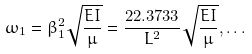<formula> <loc_0><loc_0><loc_500><loc_500>\omega _ { 1 } = \beta _ { 1 } ^ { 2 } { \sqrt { \frac { E I } { \mu } } } = { \frac { 2 2 . 3 7 3 3 } { L ^ { 2 } } } { \sqrt { \frac { E I } { \mu } } } , \dots</formula> 